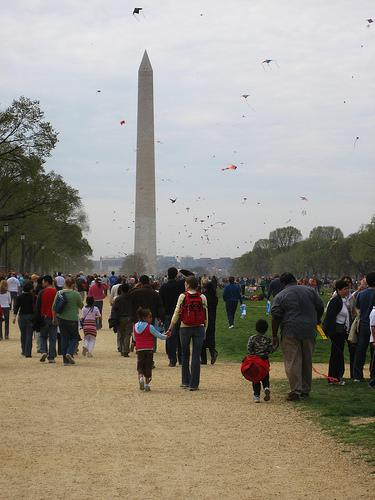Question: how would this group of people be described?
Choices:
A. A crowd.
B. A hoard.
C. A flock.
D. A pack.
Answer with the letter. Answer: A Question: where was this picture taken?
Choices:
A. San Francisco.
B. San Antonio.
C. Las Vegas.
D. Washington D.C.
Answer with the letter. Answer: D Question: what is in the background?
Choices:
A. A flock of birds.
B. Trees.
C. Herd of bison.
D. Washington Monument.
Answer with the letter. Answer: D Question: what are some of the tourists carrying on their backs?
Choices:
A. Water jugs.
B. Babies.
C. Rifles.
D. Backpacks.
Answer with the letter. Answer: D Question: who visits the Washington Monument?
Choices:
A. Americans.
B. Tourists.
C. Italians.
D. Germans.
Answer with the letter. Answer: B 